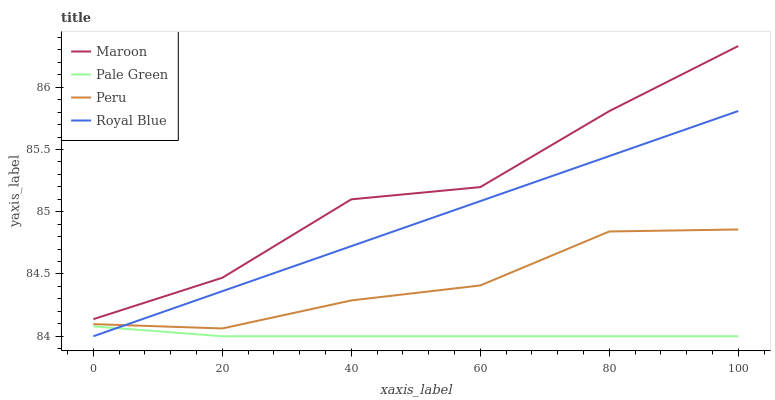Does Pale Green have the minimum area under the curve?
Answer yes or no. Yes. Does Maroon have the maximum area under the curve?
Answer yes or no. Yes. Does Peru have the minimum area under the curve?
Answer yes or no. No. Does Peru have the maximum area under the curve?
Answer yes or no. No. Is Royal Blue the smoothest?
Answer yes or no. Yes. Is Maroon the roughest?
Answer yes or no. Yes. Is Pale Green the smoothest?
Answer yes or no. No. Is Pale Green the roughest?
Answer yes or no. No. Does Peru have the lowest value?
Answer yes or no. No. Does Maroon have the highest value?
Answer yes or no. Yes. Does Peru have the highest value?
Answer yes or no. No. Is Pale Green less than Maroon?
Answer yes or no. Yes. Is Peru greater than Pale Green?
Answer yes or no. Yes. Does Pale Green intersect Maroon?
Answer yes or no. No. 